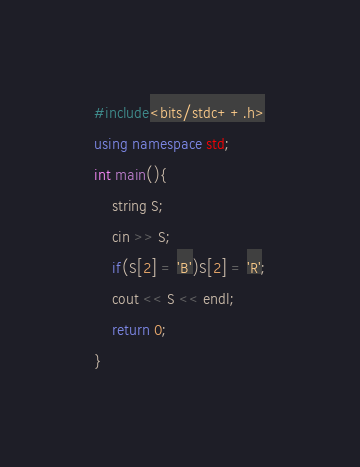Convert code to text. <code><loc_0><loc_0><loc_500><loc_500><_C++_>#include<bits/stdc++.h>
using namespace std;
int main(){
    string S;
    cin >> S;
    if(S[2] = 'B')S[2] = 'R';
    cout << S << endl;
    return 0;
}</code> 